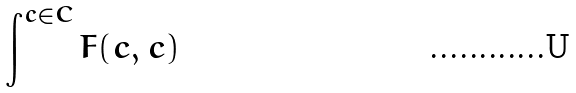Convert formula to latex. <formula><loc_0><loc_0><loc_500><loc_500>\int ^ { c \in C } F ( c , c )</formula> 